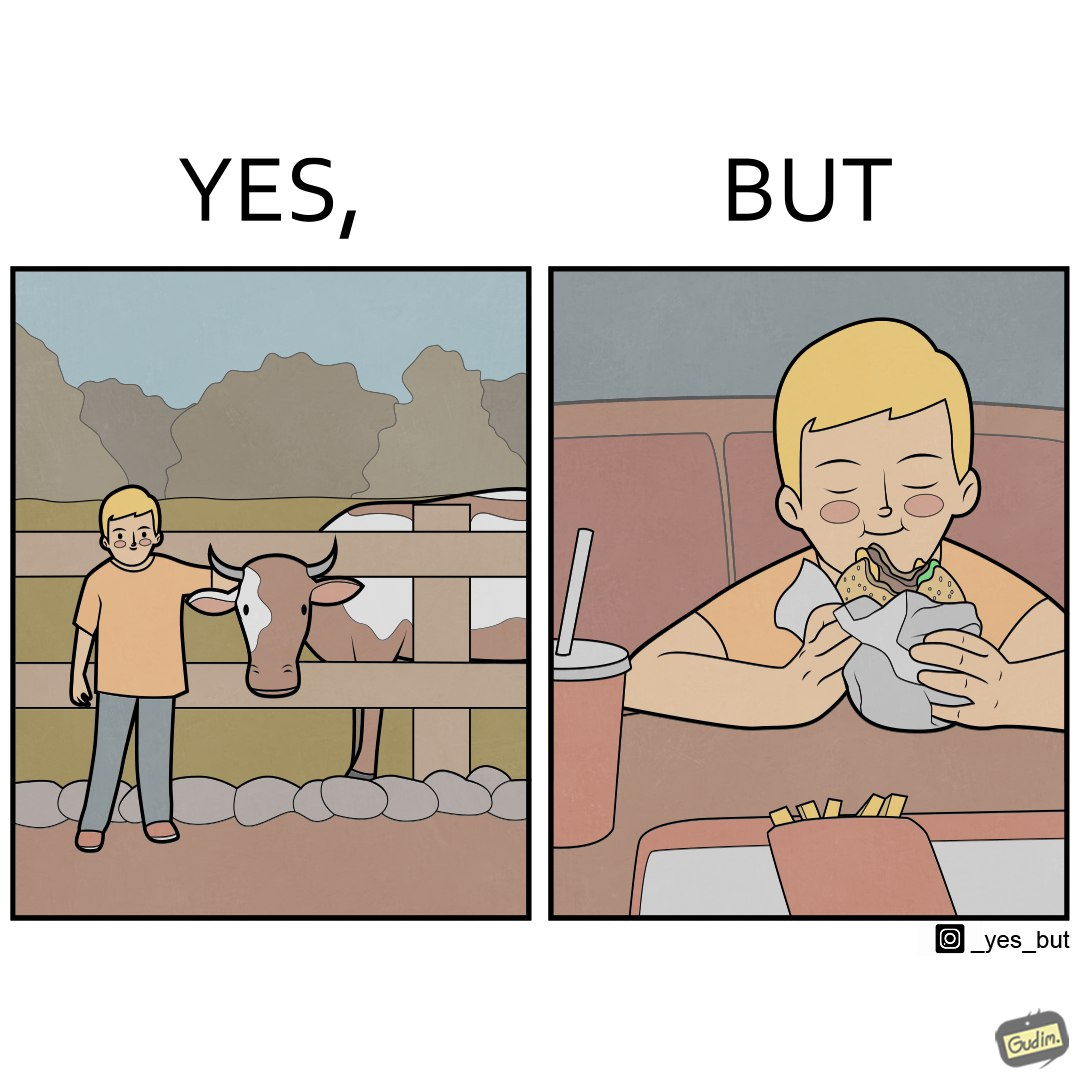Describe the contrast between the left and right parts of this image. In the left part of the image: A boy petting a cow In the right part of the image: A boy eating a hamburger 